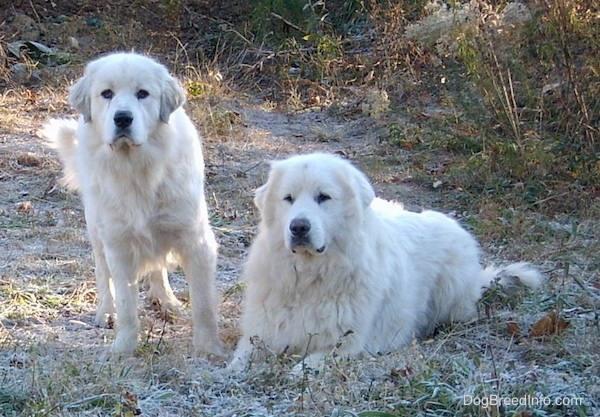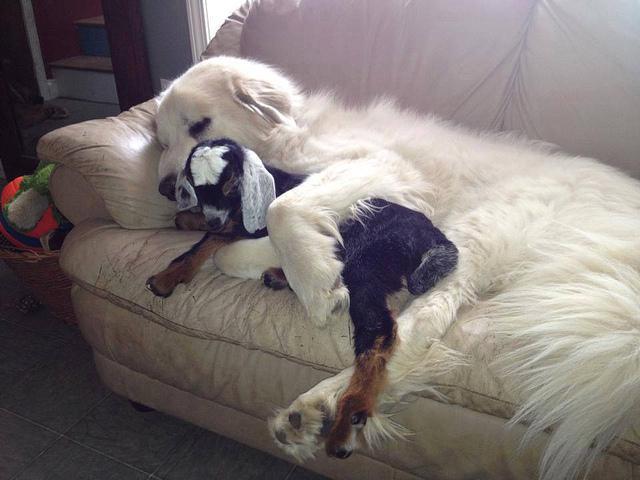The first image is the image on the left, the second image is the image on the right. Evaluate the accuracy of this statement regarding the images: "One dog's mouth is open.". Is it true? Answer yes or no. No. The first image is the image on the left, the second image is the image on the right. Analyze the images presented: Is the assertion "at least one dog is on a grass surface" valid? Answer yes or no. Yes. 